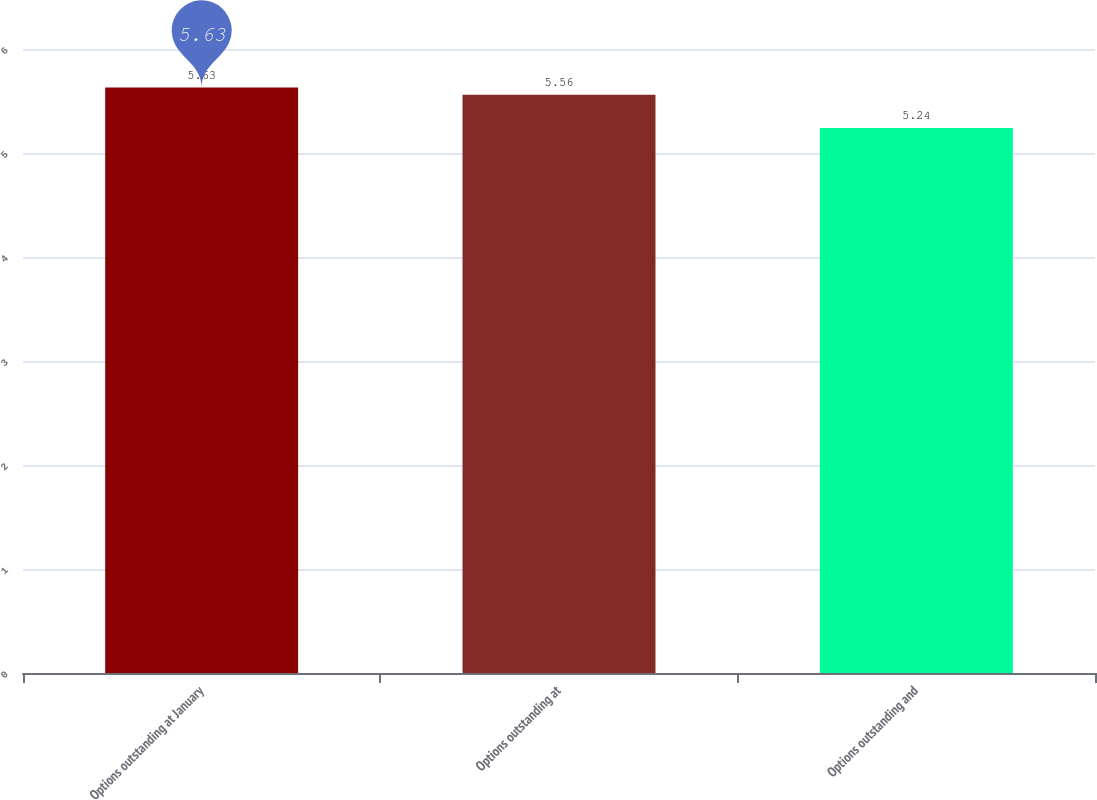Convert chart. <chart><loc_0><loc_0><loc_500><loc_500><bar_chart><fcel>Options outstanding at January<fcel>Options outstanding at<fcel>Options outstanding and<nl><fcel>5.63<fcel>5.56<fcel>5.24<nl></chart> 